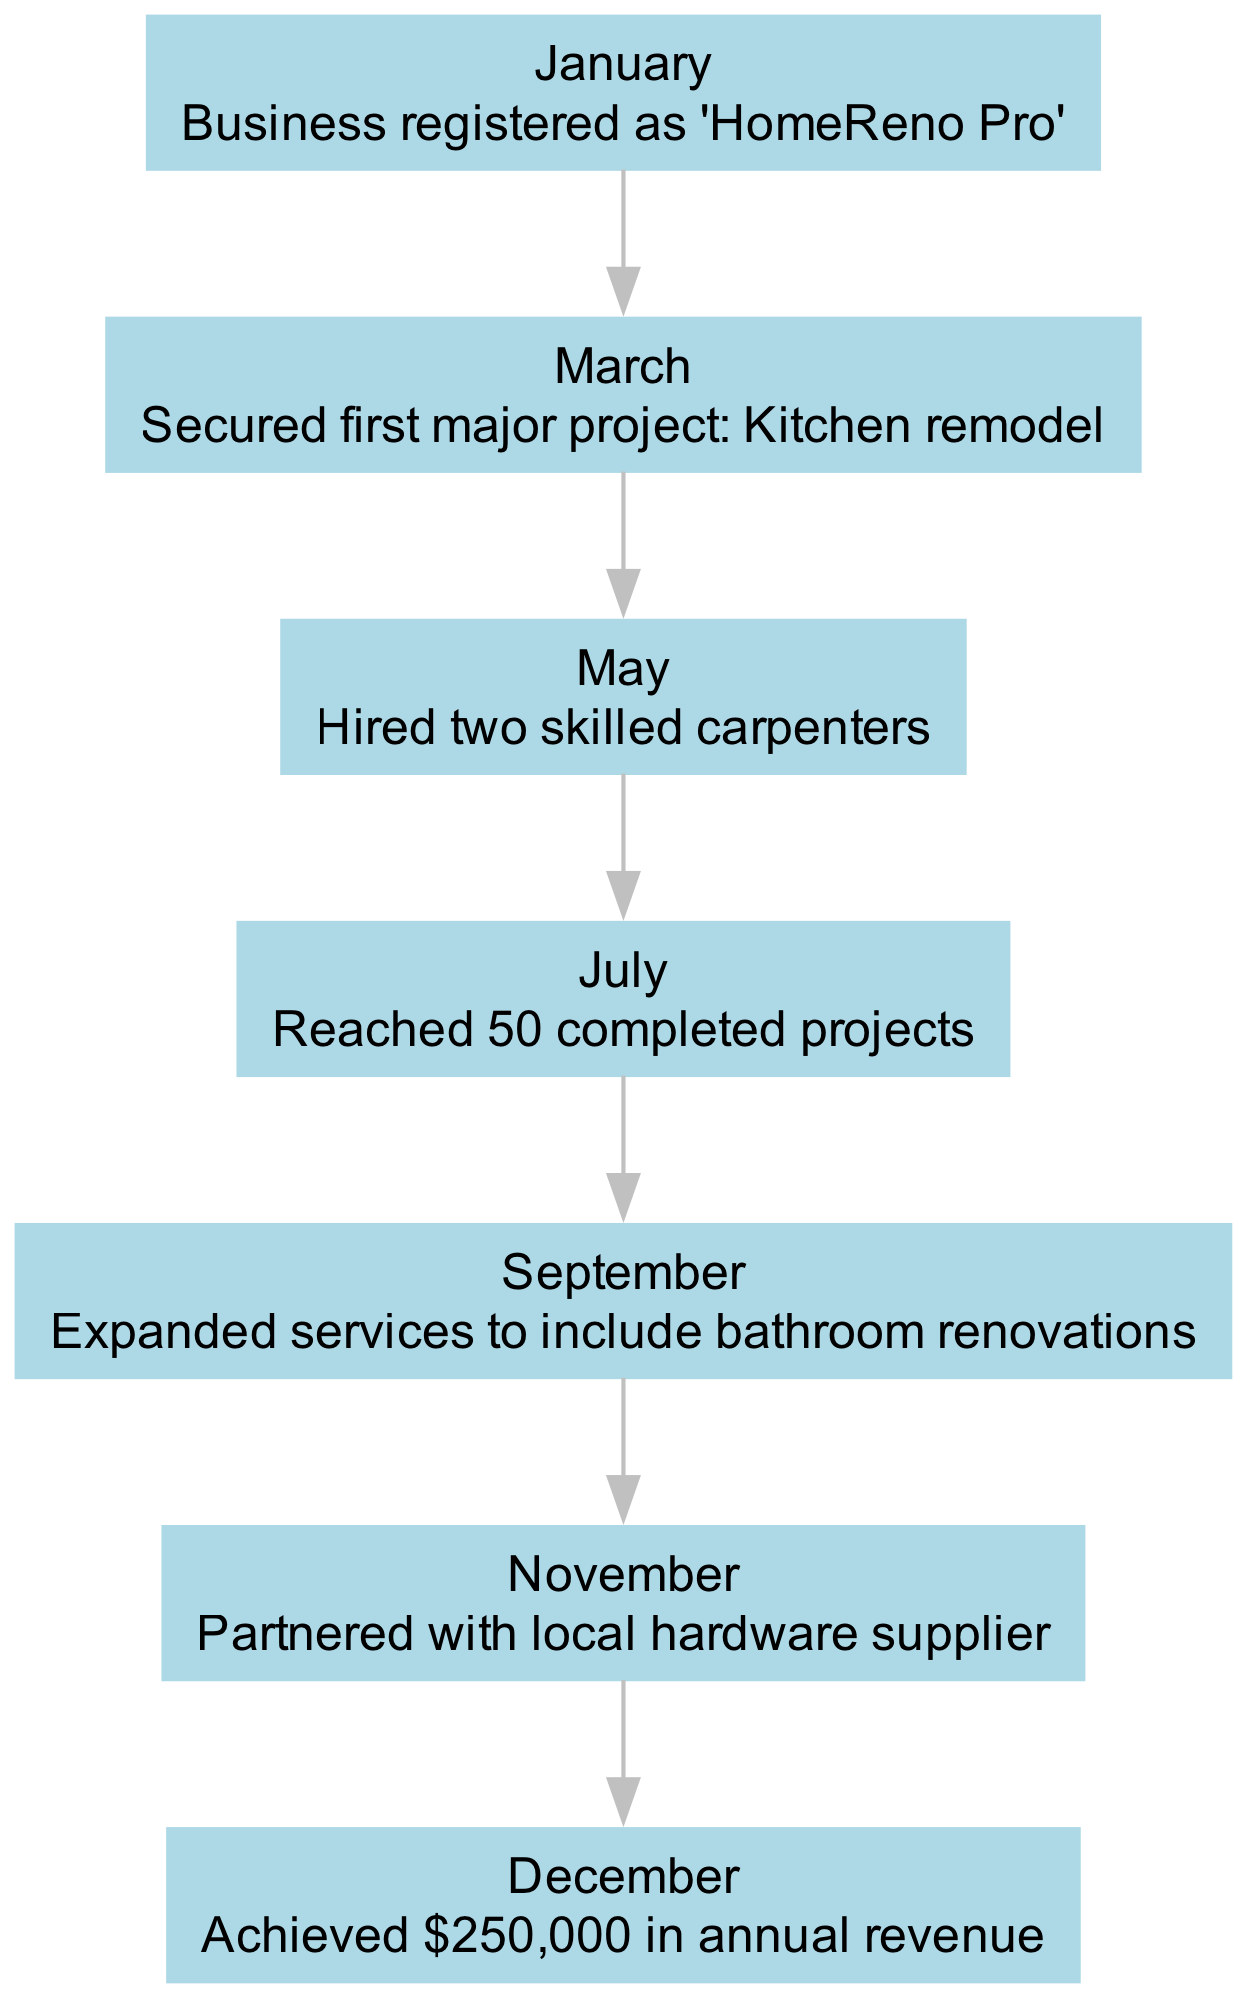What is the first milestone listed in the timeline? The first milestone listed is from January, which is "Business registered as 'HomeReno Pro'."
Answer: Business registered as 'HomeReno Pro' How many projects were completed by July? The milestone for July mentions that the company reached 50 completed projects.
Answer: 50 completed projects Which month did the company expand services? The expansion of services is noted in September when it included bathroom renovations.
Answer: September What milestone occurred in March? In March, the milestone is "Secured first major project: Kitchen remodel."
Answer: Secured first major project: Kitchen remodel How many carpenters were hired in May? The data for May states that two skilled carpenters were hired, indicating the amount was two.
Answer: Two What was the final milestone achieved in December? The milestone for December states that the company achieved $250,000 in annual revenue, which denotes the final achievement in the timeline.
Answer: Achieved $250,000 in annual revenue Was there a partnership formed during the year? Yes, the timeline for November shows that the company partnered with a local hardware supplier.
Answer: Partnered with local hardware supplier How many milestones are recorded throughout the year? By counting each unique month with an associated milestone, we find there are seven milestones documented in the timeline.
Answer: Seven In which month did the company hire skilled carpenters? The hiring of skilled carpenters is noted in May, indicating that May is the relevant month.
Answer: May What is the total annual revenue achieved by the end of the year? The milestone for December specifies that the annual revenue reached $250,000, which indicates the total for the year.
Answer: $250,000 